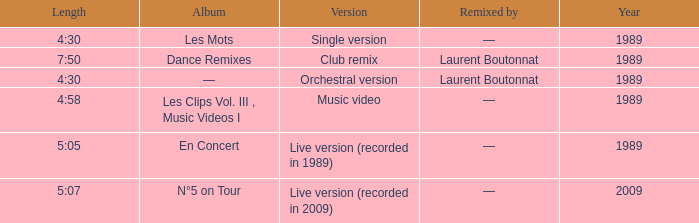Album of les mots had what lowest year? 1989.0. 